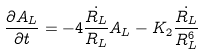<formula> <loc_0><loc_0><loc_500><loc_500>\frac { { \partial } A _ { L } } { { \partial } t } = - 4 \frac { \dot { R _ { L } } } { R _ { L } } A _ { L } - K _ { 2 } \frac { \dot { R _ { L } } } { R _ { L } ^ { 6 } }</formula> 